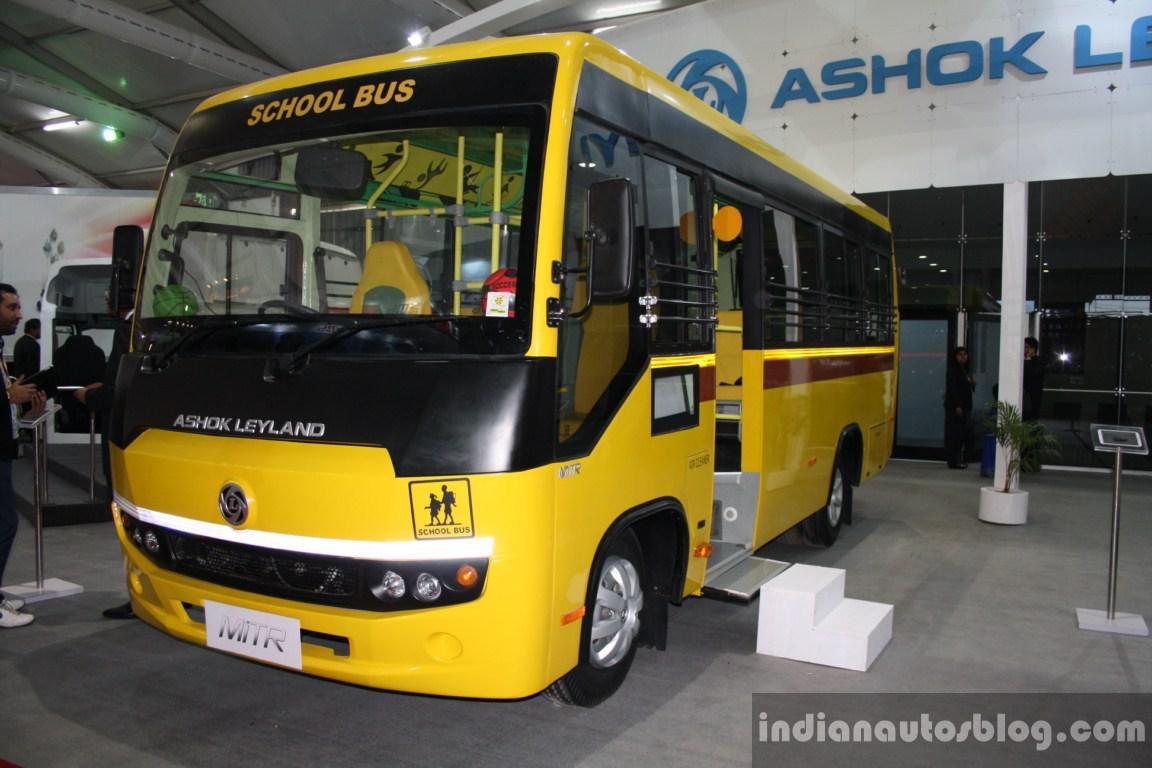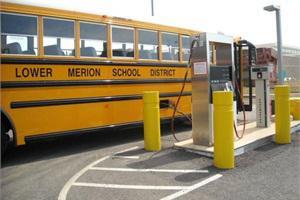The first image is the image on the left, the second image is the image on the right. For the images shown, is this caption "At least 3 school buses are parked side by side in one of the pictures." true? Answer yes or no. No. The first image is the image on the left, the second image is the image on the right. Examine the images to the left and right. Is the description "Yellow school buses are lined up side by side and facing forward in one of the images." accurate? Answer yes or no. No. 